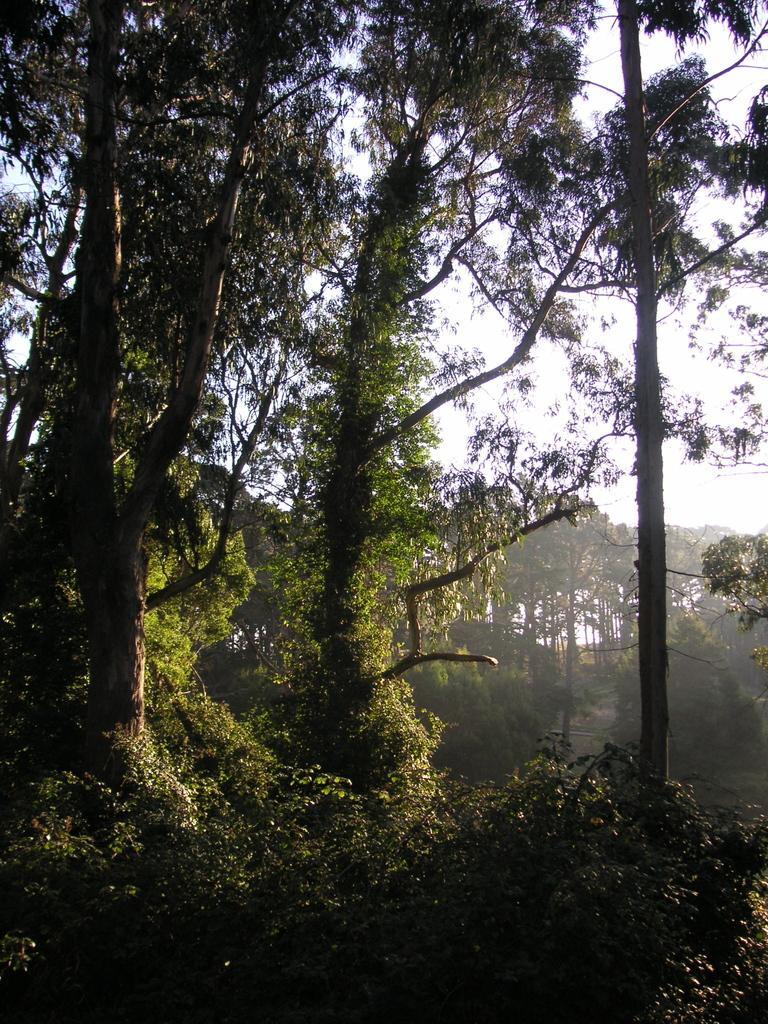Describe this image in one or two sentences. In the picture we can see a plant and trees and in the background also we can see trees and sky. 